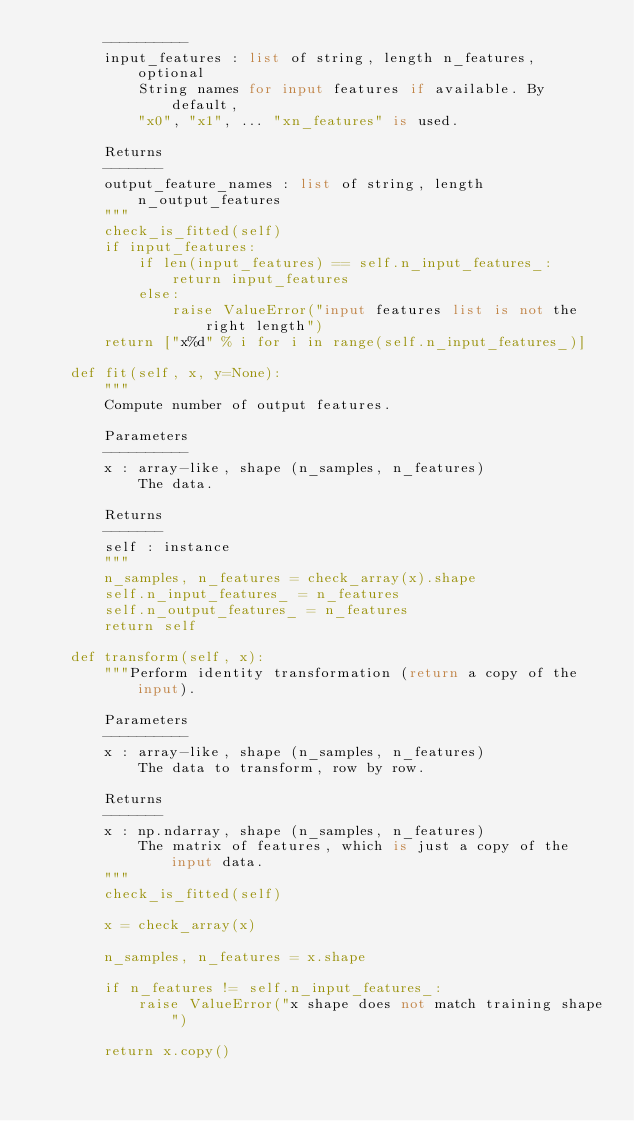Convert code to text. <code><loc_0><loc_0><loc_500><loc_500><_Python_>        ----------
        input_features : list of string, length n_features, optional
            String names for input features if available. By default,
            "x0", "x1", ... "xn_features" is used.

        Returns
        -------
        output_feature_names : list of string, length n_output_features
        """
        check_is_fitted(self)
        if input_features:
            if len(input_features) == self.n_input_features_:
                return input_features
            else:
                raise ValueError("input features list is not the right length")
        return ["x%d" % i for i in range(self.n_input_features_)]

    def fit(self, x, y=None):
        """
        Compute number of output features.

        Parameters
        ----------
        x : array-like, shape (n_samples, n_features)
            The data.

        Returns
        -------
        self : instance
        """
        n_samples, n_features = check_array(x).shape
        self.n_input_features_ = n_features
        self.n_output_features_ = n_features
        return self

    def transform(self, x):
        """Perform identity transformation (return a copy of the input).

        Parameters
        ----------
        x : array-like, shape (n_samples, n_features)
            The data to transform, row by row.

        Returns
        -------
        x : np.ndarray, shape (n_samples, n_features)
            The matrix of features, which is just a copy of the input data.
        """
        check_is_fitted(self)

        x = check_array(x)

        n_samples, n_features = x.shape

        if n_features != self.n_input_features_:
            raise ValueError("x shape does not match training shape")

        return x.copy()
</code> 